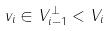<formula> <loc_0><loc_0><loc_500><loc_500>v _ { i } \in V _ { i - 1 } ^ { \perp } < V _ { i }</formula> 